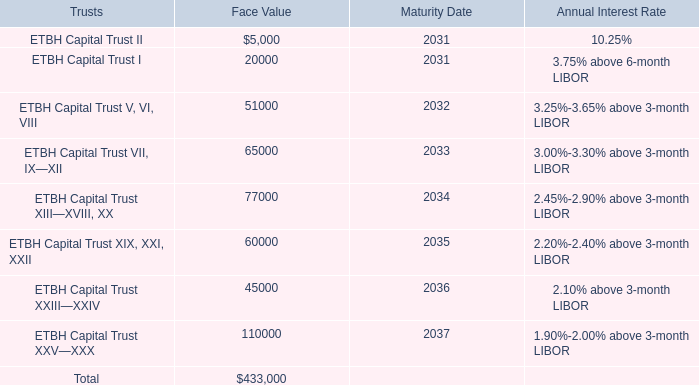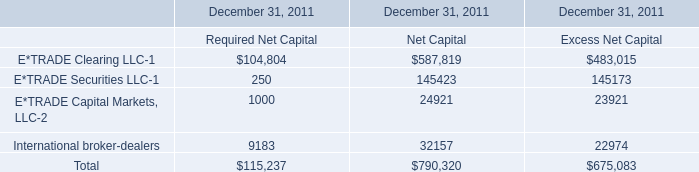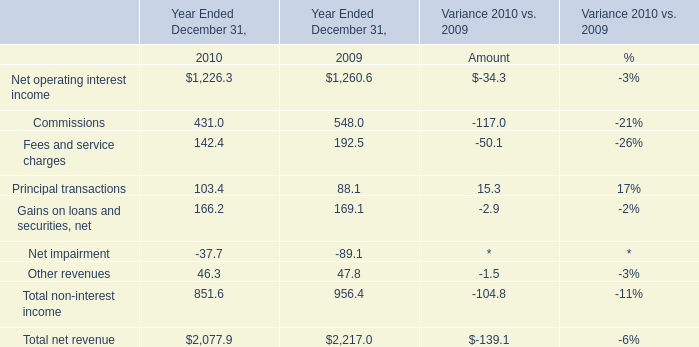What is the average amount of ETBH Capital Trust VII, IX—XII of Maturity Date, and E*TRADE Clearing LLC of December 31, 2011 Excess Net Capital ? 
Computations: ((2033.0 + 483015.0) / 2)
Answer: 242524.0. 